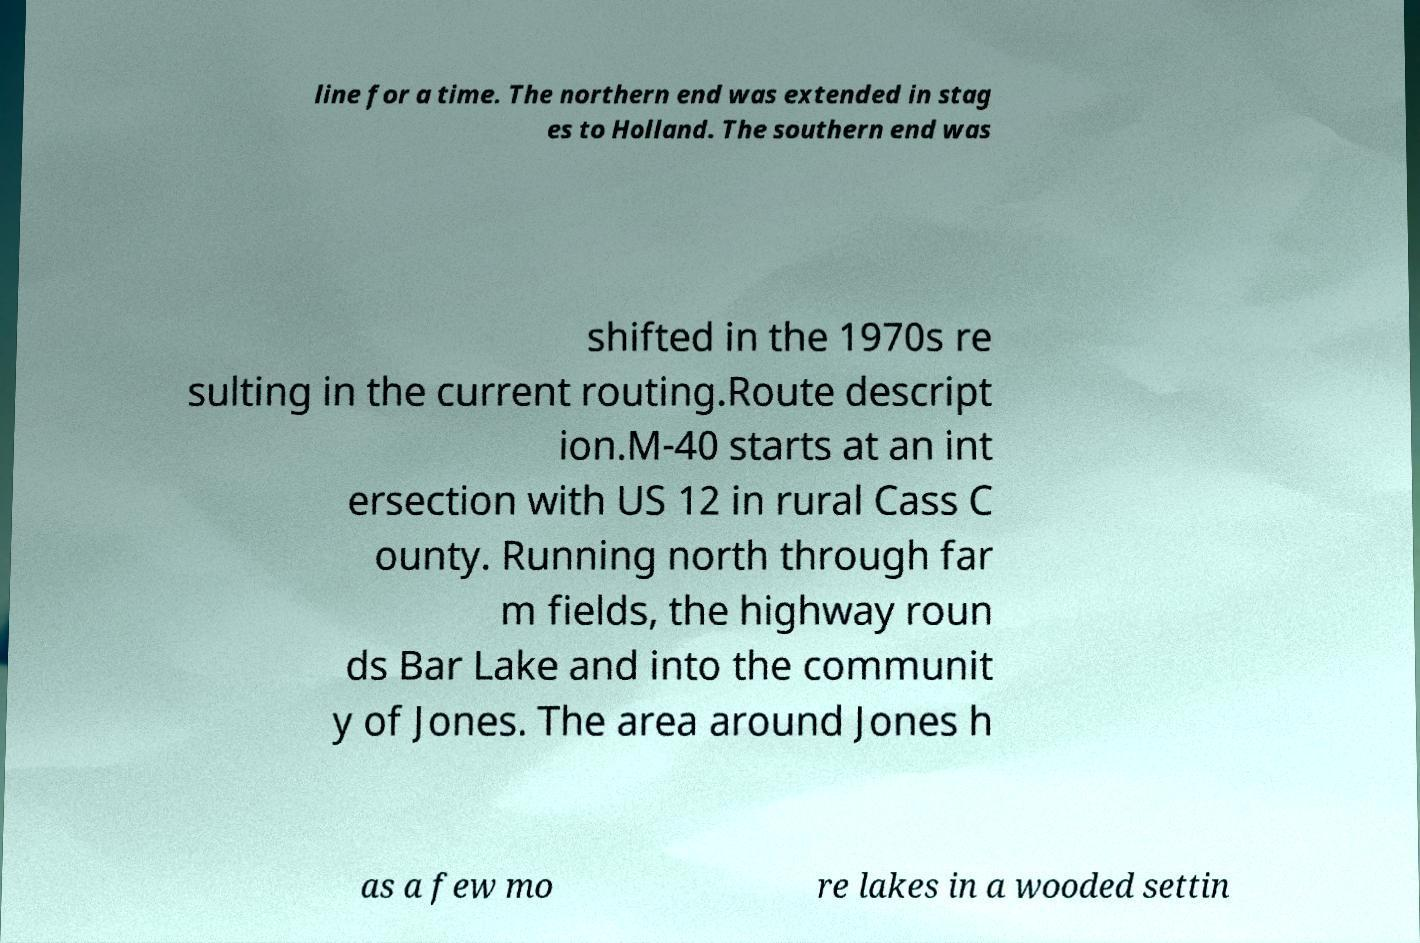Please identify and transcribe the text found in this image. line for a time. The northern end was extended in stag es to Holland. The southern end was shifted in the 1970s re sulting in the current routing.Route descript ion.M-40 starts at an int ersection with US 12 in rural Cass C ounty. Running north through far m fields, the highway roun ds Bar Lake and into the communit y of Jones. The area around Jones h as a few mo re lakes in a wooded settin 